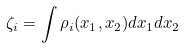Convert formula to latex. <formula><loc_0><loc_0><loc_500><loc_500>\zeta _ { i } = \int \rho _ { i } ( x _ { 1 } , x _ { 2 } ) d x _ { 1 } d x _ { 2 }</formula> 